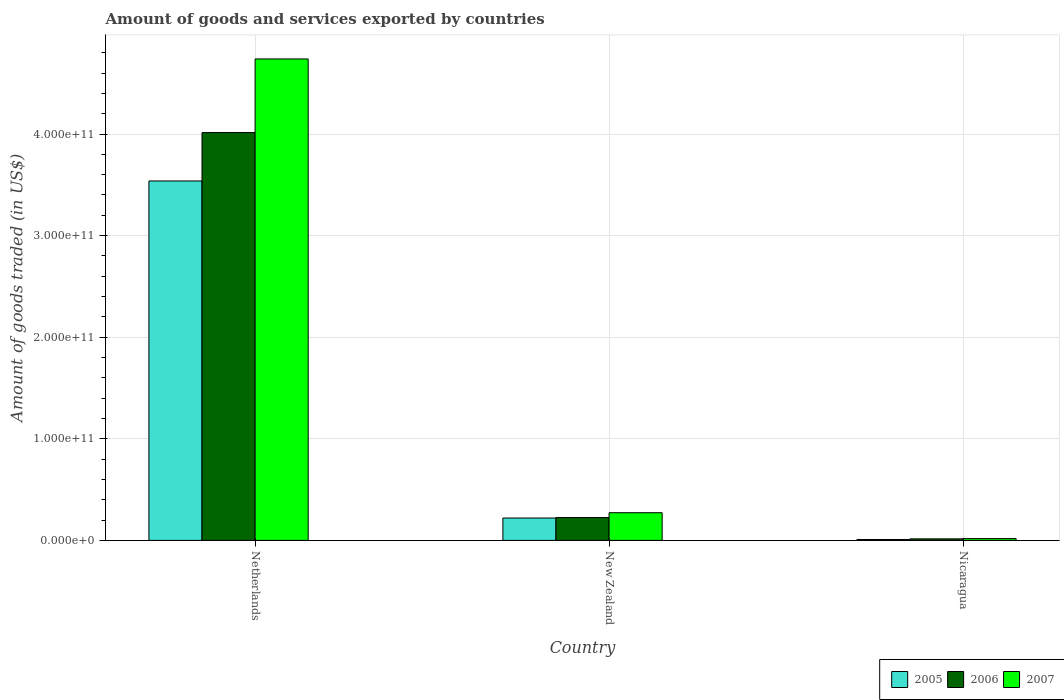Are the number of bars per tick equal to the number of legend labels?
Your answer should be very brief. Yes. Are the number of bars on each tick of the X-axis equal?
Give a very brief answer. Yes. In how many cases, is the number of bars for a given country not equal to the number of legend labels?
Offer a very short reply. 0. What is the total amount of goods and services exported in 2006 in Netherlands?
Your answer should be compact. 4.01e+11. Across all countries, what is the maximum total amount of goods and services exported in 2006?
Make the answer very short. 4.01e+11. Across all countries, what is the minimum total amount of goods and services exported in 2007?
Keep it short and to the point. 1.75e+09. In which country was the total amount of goods and services exported in 2007 maximum?
Offer a very short reply. Netherlands. In which country was the total amount of goods and services exported in 2005 minimum?
Your answer should be compact. Nicaragua. What is the total total amount of goods and services exported in 2005 in the graph?
Offer a terse response. 3.77e+11. What is the difference between the total amount of goods and services exported in 2006 in New Zealand and that in Nicaragua?
Ensure brevity in your answer.  2.10e+1. What is the difference between the total amount of goods and services exported in 2007 in Nicaragua and the total amount of goods and services exported in 2006 in Netherlands?
Offer a very short reply. -4.00e+11. What is the average total amount of goods and services exported in 2005 per country?
Provide a short and direct response. 1.26e+11. What is the difference between the total amount of goods and services exported of/in 2005 and total amount of goods and services exported of/in 2007 in Nicaragua?
Give a very brief answer. -8.73e+08. What is the ratio of the total amount of goods and services exported in 2006 in Netherlands to that in Nicaragua?
Offer a terse response. 264.9. Is the total amount of goods and services exported in 2007 in New Zealand less than that in Nicaragua?
Offer a terse response. No. Is the difference between the total amount of goods and services exported in 2005 in Netherlands and New Zealand greater than the difference between the total amount of goods and services exported in 2007 in Netherlands and New Zealand?
Keep it short and to the point. No. What is the difference between the highest and the second highest total amount of goods and services exported in 2007?
Your answer should be very brief. 4.72e+11. What is the difference between the highest and the lowest total amount of goods and services exported in 2005?
Provide a succinct answer. 3.53e+11. What does the 2nd bar from the right in Netherlands represents?
Offer a terse response. 2006. Is it the case that in every country, the sum of the total amount of goods and services exported in 2005 and total amount of goods and services exported in 2007 is greater than the total amount of goods and services exported in 2006?
Your answer should be compact. Yes. How many bars are there?
Your answer should be very brief. 9. Are all the bars in the graph horizontal?
Provide a short and direct response. No. What is the difference between two consecutive major ticks on the Y-axis?
Your response must be concise. 1.00e+11. Are the values on the major ticks of Y-axis written in scientific E-notation?
Your response must be concise. Yes. How many legend labels are there?
Provide a succinct answer. 3. What is the title of the graph?
Your answer should be very brief. Amount of goods and services exported by countries. What is the label or title of the Y-axis?
Ensure brevity in your answer.  Amount of goods traded (in US$). What is the Amount of goods traded (in US$) of 2005 in Netherlands?
Give a very brief answer. 3.54e+11. What is the Amount of goods traded (in US$) in 2006 in Netherlands?
Ensure brevity in your answer.  4.01e+11. What is the Amount of goods traded (in US$) of 2007 in Netherlands?
Provide a succinct answer. 4.74e+11. What is the Amount of goods traded (in US$) in 2005 in New Zealand?
Ensure brevity in your answer.  2.20e+1. What is the Amount of goods traded (in US$) of 2006 in New Zealand?
Ensure brevity in your answer.  2.25e+1. What is the Amount of goods traded (in US$) in 2007 in New Zealand?
Offer a very short reply. 2.72e+1. What is the Amount of goods traded (in US$) of 2005 in Nicaragua?
Offer a very short reply. 8.80e+08. What is the Amount of goods traded (in US$) in 2006 in Nicaragua?
Your answer should be very brief. 1.52e+09. What is the Amount of goods traded (in US$) of 2007 in Nicaragua?
Your answer should be compact. 1.75e+09. Across all countries, what is the maximum Amount of goods traded (in US$) of 2005?
Provide a short and direct response. 3.54e+11. Across all countries, what is the maximum Amount of goods traded (in US$) in 2006?
Keep it short and to the point. 4.01e+11. Across all countries, what is the maximum Amount of goods traded (in US$) of 2007?
Provide a short and direct response. 4.74e+11. Across all countries, what is the minimum Amount of goods traded (in US$) of 2005?
Make the answer very short. 8.80e+08. Across all countries, what is the minimum Amount of goods traded (in US$) of 2006?
Your answer should be compact. 1.52e+09. Across all countries, what is the minimum Amount of goods traded (in US$) in 2007?
Provide a succinct answer. 1.75e+09. What is the total Amount of goods traded (in US$) of 2005 in the graph?
Offer a very short reply. 3.77e+11. What is the total Amount of goods traded (in US$) of 2006 in the graph?
Provide a short and direct response. 4.25e+11. What is the total Amount of goods traded (in US$) in 2007 in the graph?
Make the answer very short. 5.03e+11. What is the difference between the Amount of goods traded (in US$) in 2005 in Netherlands and that in New Zealand?
Give a very brief answer. 3.32e+11. What is the difference between the Amount of goods traded (in US$) in 2006 in Netherlands and that in New Zealand?
Provide a succinct answer. 3.79e+11. What is the difference between the Amount of goods traded (in US$) of 2007 in Netherlands and that in New Zealand?
Offer a terse response. 4.47e+11. What is the difference between the Amount of goods traded (in US$) in 2005 in Netherlands and that in Nicaragua?
Your answer should be very brief. 3.53e+11. What is the difference between the Amount of goods traded (in US$) of 2006 in Netherlands and that in Nicaragua?
Offer a very short reply. 4.00e+11. What is the difference between the Amount of goods traded (in US$) in 2007 in Netherlands and that in Nicaragua?
Offer a very short reply. 4.72e+11. What is the difference between the Amount of goods traded (in US$) in 2005 in New Zealand and that in Nicaragua?
Give a very brief answer. 2.11e+1. What is the difference between the Amount of goods traded (in US$) in 2006 in New Zealand and that in Nicaragua?
Ensure brevity in your answer.  2.10e+1. What is the difference between the Amount of goods traded (in US$) in 2007 in New Zealand and that in Nicaragua?
Your answer should be very brief. 2.55e+1. What is the difference between the Amount of goods traded (in US$) of 2005 in Netherlands and the Amount of goods traded (in US$) of 2006 in New Zealand?
Your response must be concise. 3.31e+11. What is the difference between the Amount of goods traded (in US$) of 2005 in Netherlands and the Amount of goods traded (in US$) of 2007 in New Zealand?
Your answer should be very brief. 3.27e+11. What is the difference between the Amount of goods traded (in US$) of 2006 in Netherlands and the Amount of goods traded (in US$) of 2007 in New Zealand?
Your answer should be compact. 3.74e+11. What is the difference between the Amount of goods traded (in US$) of 2005 in Netherlands and the Amount of goods traded (in US$) of 2006 in Nicaragua?
Give a very brief answer. 3.52e+11. What is the difference between the Amount of goods traded (in US$) of 2005 in Netherlands and the Amount of goods traded (in US$) of 2007 in Nicaragua?
Provide a short and direct response. 3.52e+11. What is the difference between the Amount of goods traded (in US$) in 2006 in Netherlands and the Amount of goods traded (in US$) in 2007 in Nicaragua?
Your answer should be very brief. 4.00e+11. What is the difference between the Amount of goods traded (in US$) in 2005 in New Zealand and the Amount of goods traded (in US$) in 2006 in Nicaragua?
Provide a succinct answer. 2.05e+1. What is the difference between the Amount of goods traded (in US$) of 2005 in New Zealand and the Amount of goods traded (in US$) of 2007 in Nicaragua?
Provide a short and direct response. 2.03e+1. What is the difference between the Amount of goods traded (in US$) of 2006 in New Zealand and the Amount of goods traded (in US$) of 2007 in Nicaragua?
Provide a short and direct response. 2.07e+1. What is the average Amount of goods traded (in US$) in 2005 per country?
Give a very brief answer. 1.26e+11. What is the average Amount of goods traded (in US$) in 2006 per country?
Give a very brief answer. 1.42e+11. What is the average Amount of goods traded (in US$) of 2007 per country?
Your response must be concise. 1.68e+11. What is the difference between the Amount of goods traded (in US$) of 2005 and Amount of goods traded (in US$) of 2006 in Netherlands?
Your response must be concise. -4.76e+1. What is the difference between the Amount of goods traded (in US$) in 2005 and Amount of goods traded (in US$) in 2007 in Netherlands?
Your answer should be compact. -1.20e+11. What is the difference between the Amount of goods traded (in US$) in 2006 and Amount of goods traded (in US$) in 2007 in Netherlands?
Your response must be concise. -7.25e+1. What is the difference between the Amount of goods traded (in US$) in 2005 and Amount of goods traded (in US$) in 2006 in New Zealand?
Offer a terse response. -4.80e+08. What is the difference between the Amount of goods traded (in US$) in 2005 and Amount of goods traded (in US$) in 2007 in New Zealand?
Offer a terse response. -5.23e+09. What is the difference between the Amount of goods traded (in US$) of 2006 and Amount of goods traded (in US$) of 2007 in New Zealand?
Your answer should be compact. -4.75e+09. What is the difference between the Amount of goods traded (in US$) of 2005 and Amount of goods traded (in US$) of 2006 in Nicaragua?
Provide a short and direct response. -6.35e+08. What is the difference between the Amount of goods traded (in US$) in 2005 and Amount of goods traded (in US$) in 2007 in Nicaragua?
Keep it short and to the point. -8.73e+08. What is the difference between the Amount of goods traded (in US$) in 2006 and Amount of goods traded (in US$) in 2007 in Nicaragua?
Offer a terse response. -2.39e+08. What is the ratio of the Amount of goods traded (in US$) in 2005 in Netherlands to that in New Zealand?
Your answer should be compact. 16.07. What is the ratio of the Amount of goods traded (in US$) in 2006 in Netherlands to that in New Zealand?
Your response must be concise. 17.84. What is the ratio of the Amount of goods traded (in US$) in 2007 in Netherlands to that in New Zealand?
Provide a short and direct response. 17.4. What is the ratio of the Amount of goods traded (in US$) in 2005 in Netherlands to that in Nicaragua?
Offer a terse response. 401.82. What is the ratio of the Amount of goods traded (in US$) in 2006 in Netherlands to that in Nicaragua?
Your response must be concise. 264.9. What is the ratio of the Amount of goods traded (in US$) of 2007 in Netherlands to that in Nicaragua?
Offer a terse response. 270.18. What is the ratio of the Amount of goods traded (in US$) in 2005 in New Zealand to that in Nicaragua?
Ensure brevity in your answer.  25. What is the ratio of the Amount of goods traded (in US$) of 2006 in New Zealand to that in Nicaragua?
Provide a short and direct response. 14.85. What is the ratio of the Amount of goods traded (in US$) of 2007 in New Zealand to that in Nicaragua?
Give a very brief answer. 15.53. What is the difference between the highest and the second highest Amount of goods traded (in US$) in 2005?
Your answer should be compact. 3.32e+11. What is the difference between the highest and the second highest Amount of goods traded (in US$) in 2006?
Offer a very short reply. 3.79e+11. What is the difference between the highest and the second highest Amount of goods traded (in US$) in 2007?
Offer a very short reply. 4.47e+11. What is the difference between the highest and the lowest Amount of goods traded (in US$) in 2005?
Keep it short and to the point. 3.53e+11. What is the difference between the highest and the lowest Amount of goods traded (in US$) of 2006?
Your answer should be compact. 4.00e+11. What is the difference between the highest and the lowest Amount of goods traded (in US$) of 2007?
Ensure brevity in your answer.  4.72e+11. 